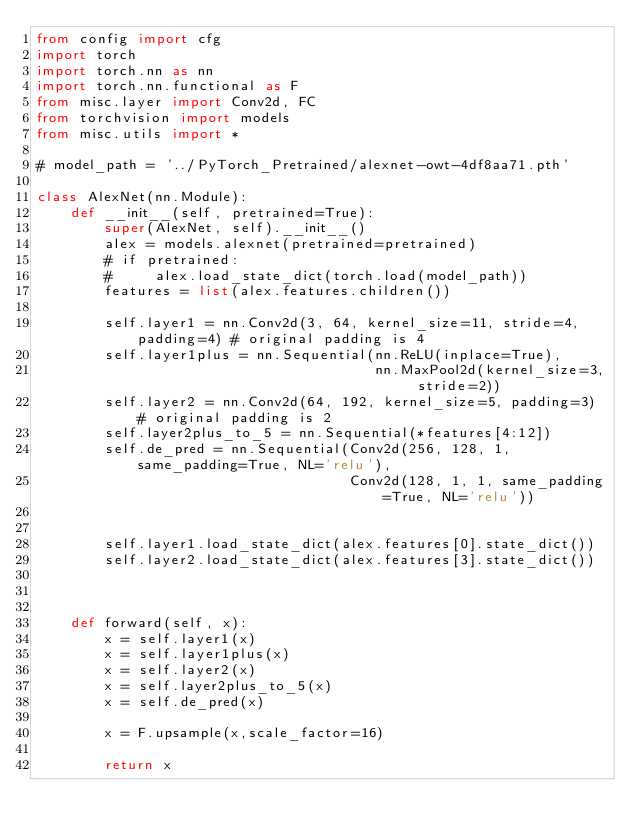Convert code to text. <code><loc_0><loc_0><loc_500><loc_500><_Python_>from config import cfg
import torch
import torch.nn as nn
import torch.nn.functional as F
from misc.layer import Conv2d, FC
from torchvision import models
from misc.utils import *

# model_path = '../PyTorch_Pretrained/alexnet-owt-4df8aa71.pth'

class AlexNet(nn.Module):
    def __init__(self, pretrained=True):
        super(AlexNet, self).__init__()
        alex = models.alexnet(pretrained=pretrained)
        # if pretrained:
        #     alex.load_state_dict(torch.load(model_path))
        features = list(alex.features.children())
        
        self.layer1 = nn.Conv2d(3, 64, kernel_size=11, stride=4, padding=4) # original padding is 4
        self.layer1plus = nn.Sequential(nn.ReLU(inplace=True),
                                        nn.MaxPool2d(kernel_size=3, stride=2))
        self.layer2 = nn.Conv2d(64, 192, kernel_size=5, padding=3) # original padding is 2
        self.layer2plus_to_5 = nn.Sequential(*features[4:12])
        self.de_pred = nn.Sequential(Conv2d(256, 128, 1, same_padding=True, NL='relu'),
                                     Conv2d(128, 1, 1, same_padding=True, NL='relu'))


        self.layer1.load_state_dict(alex.features[0].state_dict())
        self.layer2.load_state_dict(alex.features[3].state_dict())



    def forward(self, x):
        x = self.layer1(x) 
        x = self.layer1plus(x)  
        x = self.layer2(x)
        x = self.layer2plus_to_5(x)  
        x = self.de_pred(x)

        x = F.upsample(x,scale_factor=16)

        return x</code> 